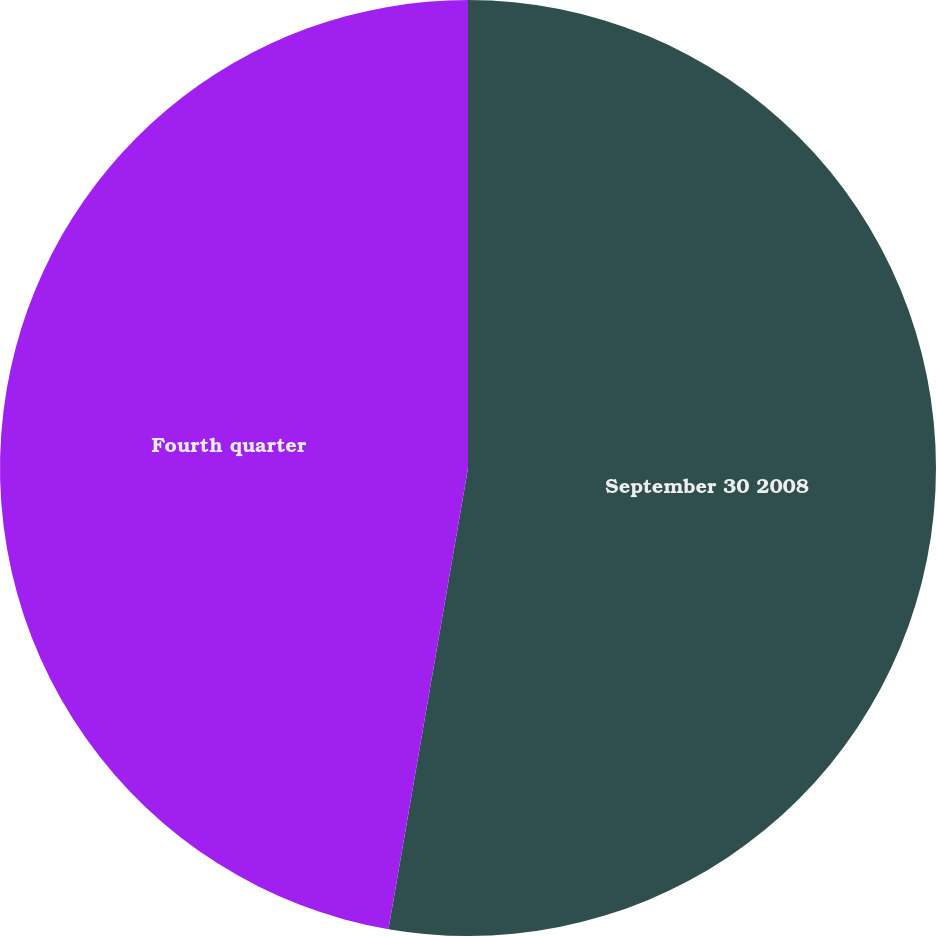Convert chart. <chart><loc_0><loc_0><loc_500><loc_500><pie_chart><fcel>September 30 2008<fcel>Fourth quarter<nl><fcel>52.72%<fcel>47.28%<nl></chart> 